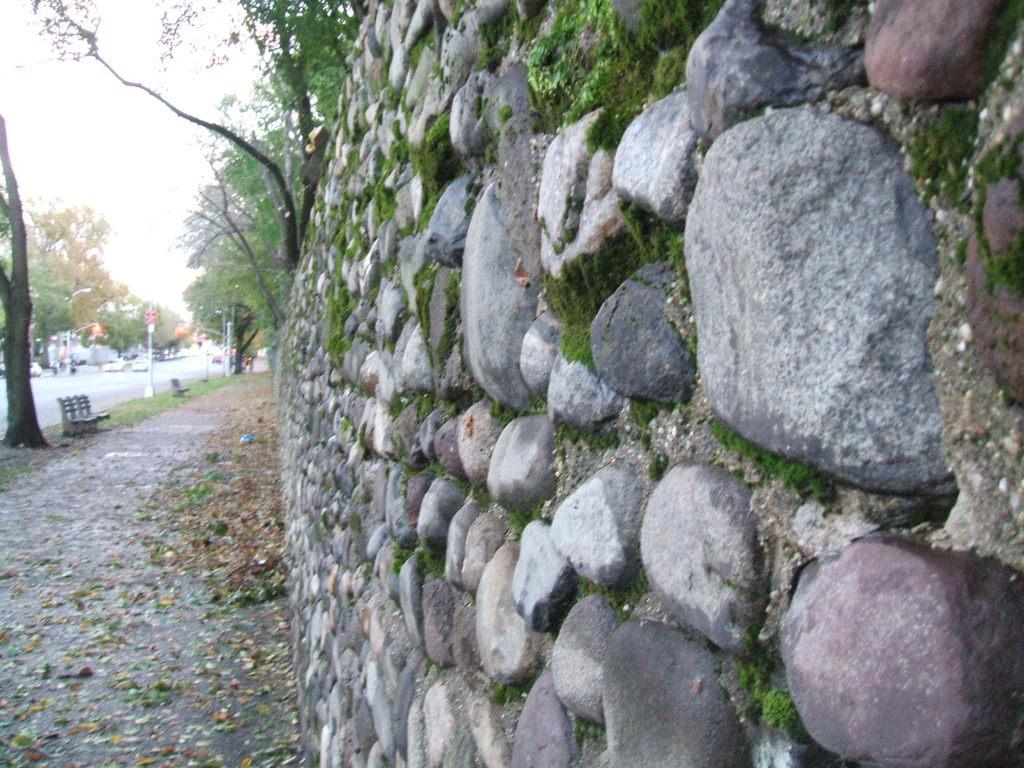What type of structure is in the image? There is a stone wall in the image. Where is the bench located in relation to the wall? The bench is on the left side of the wall. What type of vegetation is present in the image? Trees are present in the image. What other objects can be seen in the image? Poles are visible in the image. What is happening on the road in the image? There are vehicles on the road in the image. What can be seen in the background of the image? The sky is visible behind the trees. What type of manager is sitting on the bench in the image? There is no manager present in the image; it only features a stone wall, a bench, trees, poles, vehicles, and the sky. How many thumb-sized ladybugs can be seen crawling on the stone wall in the image? There are no ladybugs present in the image, so it is not possible to determine the number of thumb-sized ladybugs. 